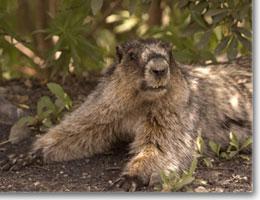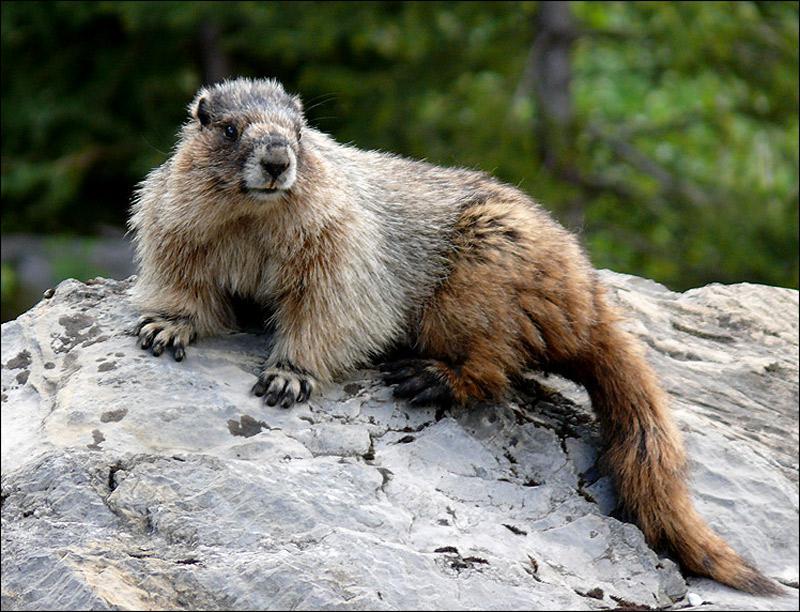The first image is the image on the left, the second image is the image on the right. For the images displayed, is the sentence "There are two marmots on rocks." factually correct? Answer yes or no. No. 